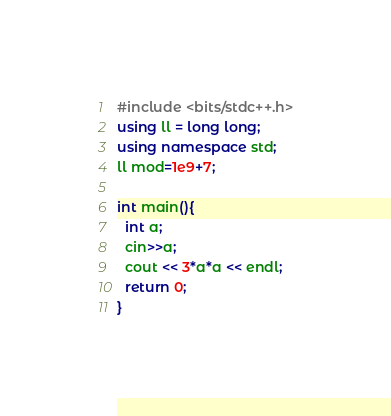<code> <loc_0><loc_0><loc_500><loc_500><_C++_>#include <bits/stdc++.h>
using ll = long long;
using namespace std;
ll mod=1e9+7;

int main(){
  int a;
  cin>>a;
  cout << 3*a*a << endl;
  return 0;
}
</code> 